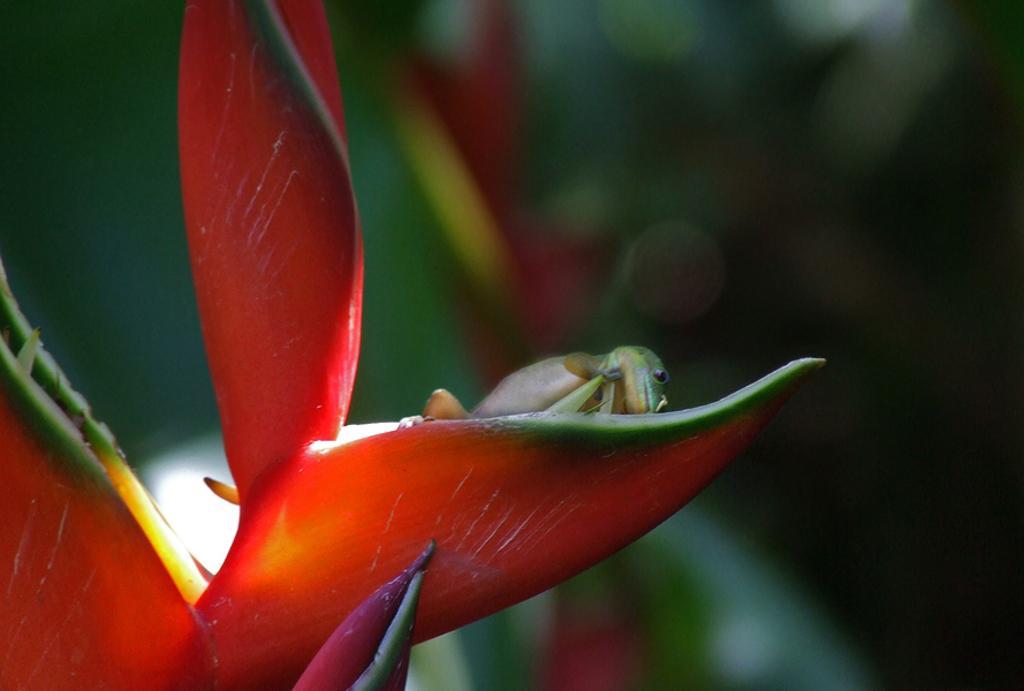Please provide a concise description of this image. In this image, we can see a lizard on a flower. In the background, image is blurred. 